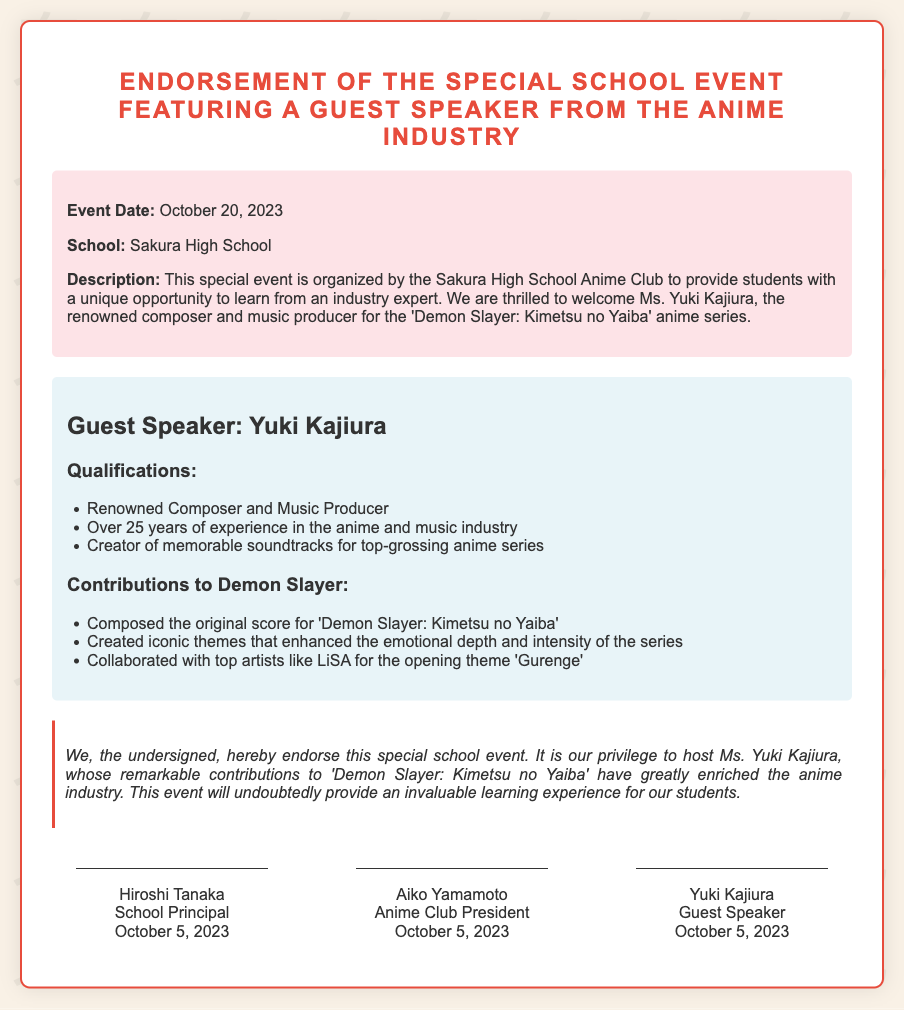What is the name of the guest speaker? The guest speaker is named Yuki Kajiura, as stated in the document.
Answer: Yuki Kajiura What is the date of the special school event? The event date is specified as October 20, 2023, in the event details section.
Answer: October 20, 2023 Who endorsed the event as the School Principal? The endorsement shows that Hiroshi Tanaka is the School Principal who signed the document.
Answer: Hiroshi Tanaka How many years of experience does the guest speaker have? It is mentioned that Yuki Kajiura has over 25 years of experience in the anime and music industry.
Answer: Over 25 years What series is specifically mentioned in connection with the guest speaker's contributions? The document refers specifically to the series 'Demon Slayer: Kimetsu no Yaiba' regarding Yuki Kajiura's contributions.
Answer: Demon Slayer: Kimetsu no Yaiba What is the title of the opening theme by LiSA mentioned in the document? The document states that the opening theme by LiSA is 'Gurenge.'
Answer: Gurenge What kind of event is being organized? The document describes the event as a unique opportunity to learn from an industry expert.
Answer: Special School Event What did the undersigned declare about the event? The undersigned declared that hosting the guest speaker would provide an invaluable learning experience for students.
Answer: Invaluable learning experience 